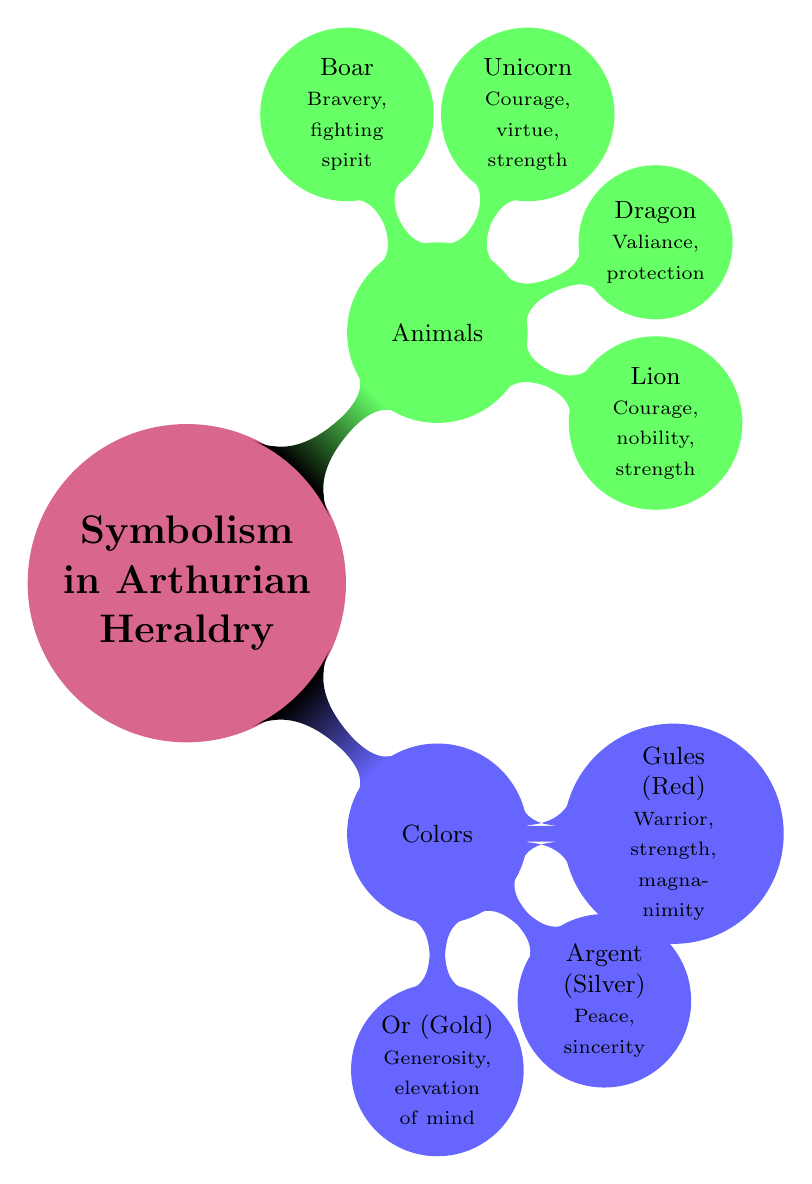What are the primary colors used in Arthurian heraldry? The diagram lists three primary colors: Or (Gold), Argent (Silver), and Gules (Red). Each of these colors is directly connected to the "Colors" node under the "Symbolism in Arthurian Heraldry."
Answer: Or, Argent, Gules How many animals are depicted in the animals section? By looking at the "Animals" node, it is clear that there are four children nodes below it, each representing a different animal. This indicates the count of animals listed is four.
Answer: 4 What does the color Gules symbolize? The diagram shows that Gules (Red) is associated with "Warrior, strength, magnanimity." Therefore, the symbolism attributed to Gules is directly given in the text associated with its node.
Answer: Warrior, strength, magnanimity Which animal symbolizes valiance? According to the diagram, the "Dragon" is the animal that represents valiance and protection. This is noted next to the node for the Dragon under the "Animals" section, which summarizes its symbolism directly.
Answer: Dragon How are the concepts of colors and animals related in the diagram? The diagram illustrates a hierarchical structure where both "Colors" and "Animals" branch out from the main concept of "Symbolism in Arthurian Heraldry." This connection shows that both categories are essential elements of heraldry symbolism, but there is no direct relationship mentioned between specific colors and animals.
Answer: Both essential elements of heraldry symbolism What does the Unicorn symbolize in Arthurian heraldry? The Unicorn node in the "Animals" section states that it symbolizes "Courage, virtue, strength." This information is directly found in the associated text of its node in the diagram.
Answer: Courage, virtue, strength 